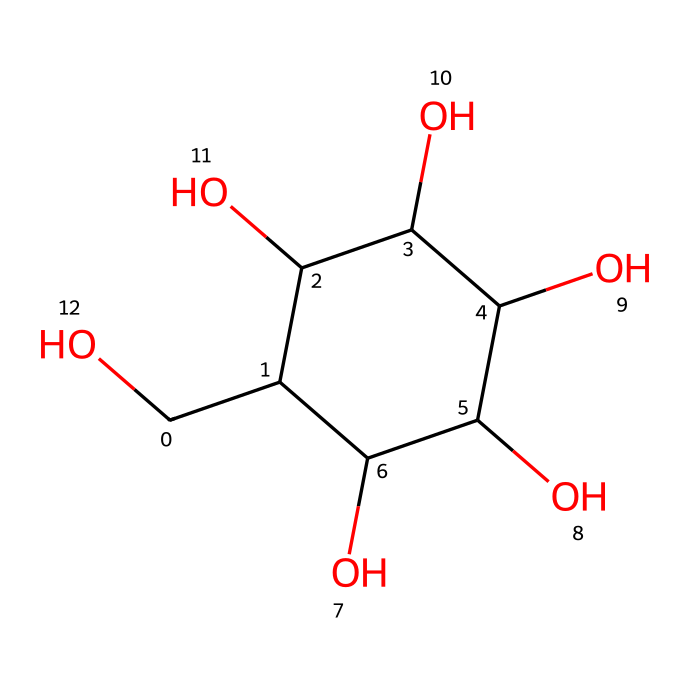How many carbon atoms are present in glucose? Count the carbon (C) atoms in the SMILES representation. There are six 'C' letters, indicating six carbon atoms in the structure.
Answer: six What is the molecular formula of glucose? The molecular formula can be deduced from the structure, indicating the number of each type of atom. From the structure, glucose comprises six carbons, twelve hydrogens, and six oxygens, resulting in the formula C6H12O6.
Answer: C6H12O6 What type of carbohydrate is glucose classified as? Glucose is a simple sugar or monosaccharide, as it consists of a single sugar unit, and this can be inferred from its structure which does not consist of multiple sugar units linked together.
Answer: monosaccharide How many hydroxyl (–OH) groups are present in glucose? By examining the structure, we can identify the hydroxyl groups; each –OH group corresponds to the 'O' directly bonded to a 'C'. There are five hydroxyl groups in the glucose structure.
Answer: five What is the configuration of the anomeric carbon in glucose? The anomeric carbon is the first carbon in the ring structure that is bonded to two oxygen atoms; this is typically carbon one (C1) in glucose, which is in the α or β configuration depending on its specific orientation. However, common glucose in solution is mostly β, where the –OH on C1 is upwards compared to C6 in the cyclic form.
Answer: beta Which functional groups are dominant in glucose? The dominant functional groups in glucose are the hydroxyl (-OH) groups, which contribute to its properties as a carbohydrate. There are also aldehyde (-CHO) group characteristics observed due to its role in metabolism, but the hydroxyl groups are primarily determining its nature as a sugar.
Answer: hydroxyl groups 